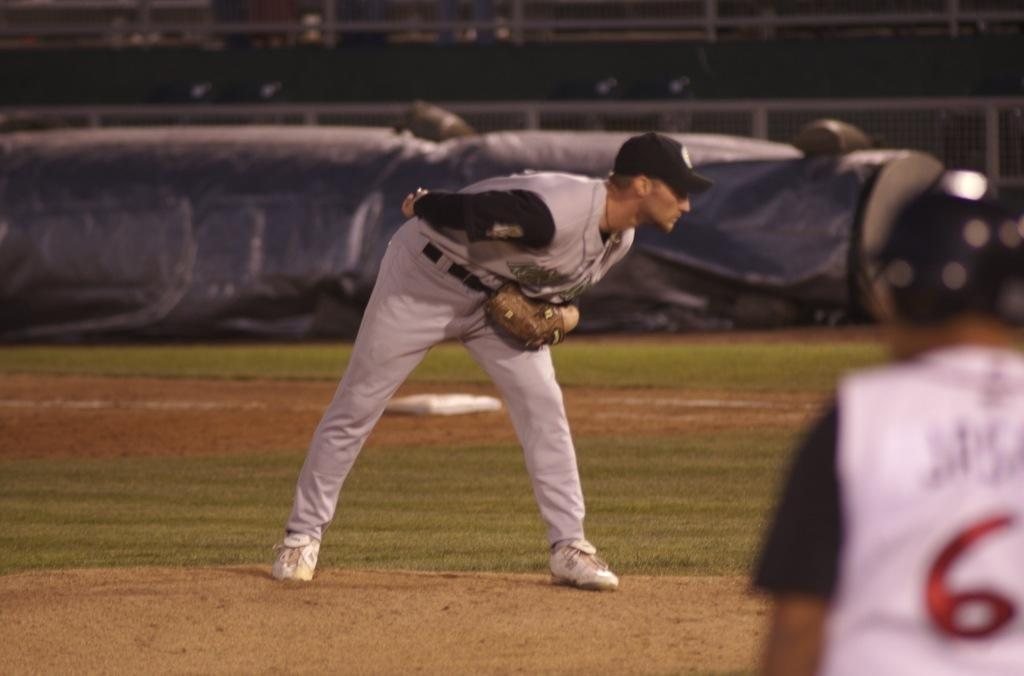<image>
Write a terse but informative summary of the picture. Number 6 watches the pitcher on the other team. 